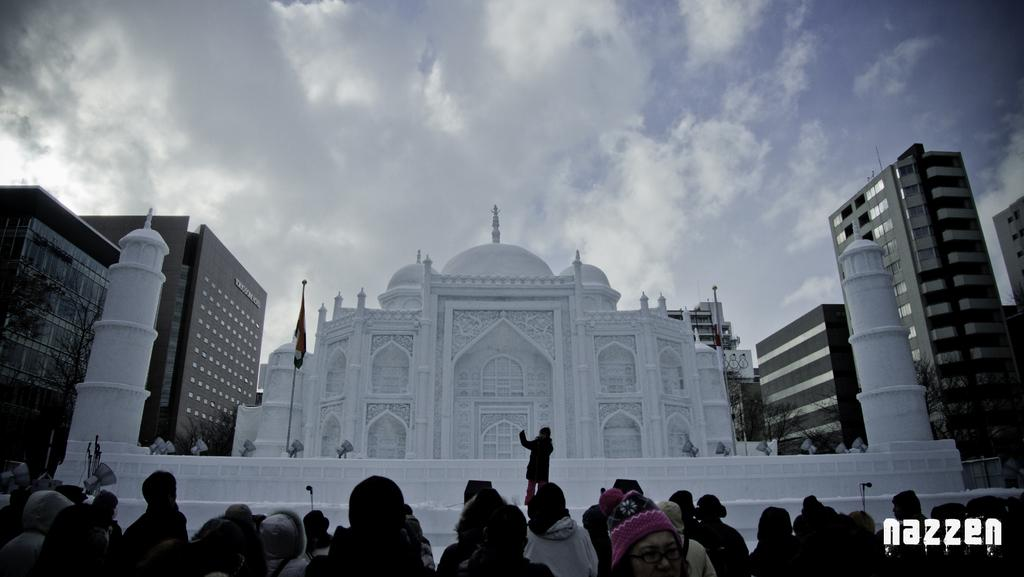What is located at the bottom of the image? There are people standing at the bottom of the image. What can be seen behind the people? There are buildings behind the people. What type of natural elements are visible at the top of the image? There are clouds visible at the top of the image. What is visible in the background of the image? The sky is visible at the top of the image. How many minutes are visible in the image? There are no minutes visible in the image; it features people, buildings, clouds, and the sky. What type of stem is present in the image? There is no stem present in the image. 